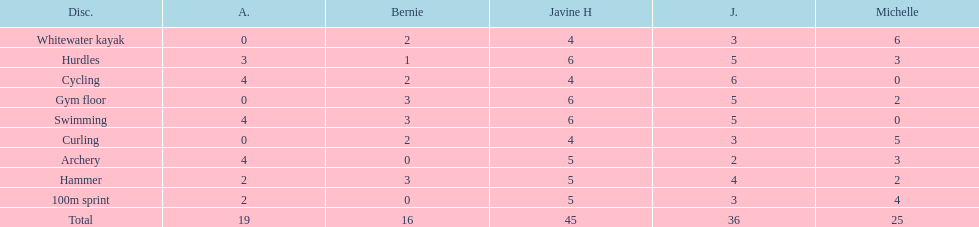Who had her best score in cycling? Julia. 